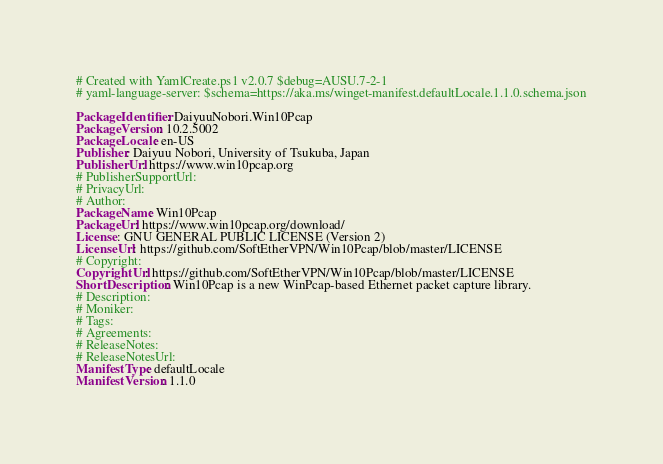Convert code to text. <code><loc_0><loc_0><loc_500><loc_500><_YAML_># Created with YamlCreate.ps1 v2.0.7 $debug=AUSU.7-2-1
# yaml-language-server: $schema=https://aka.ms/winget-manifest.defaultLocale.1.1.0.schema.json

PackageIdentifier: DaiyuuNobori.Win10Pcap
PackageVersion: 10.2.5002
PackageLocale: en-US
Publisher: Daiyuu Nobori, University of Tsukuba, Japan
PublisherUrl: https://www.win10pcap.org
# PublisherSupportUrl: 
# PrivacyUrl: 
# Author: 
PackageName: Win10Pcap
PackageUrl: https://www.win10pcap.org/download/
License: GNU GENERAL PUBLIC LICENSE (Version 2)
LicenseUrl: https://github.com/SoftEtherVPN/Win10Pcap/blob/master/LICENSE
# Copyright: 
CopyrightUrl: https://github.com/SoftEtherVPN/Win10Pcap/blob/master/LICENSE
ShortDescription: Win10Pcap is a new WinPcap-based Ethernet packet capture library.
# Description: 
# Moniker: 
# Tags: 
# Agreements: 
# ReleaseNotes: 
# ReleaseNotesUrl: 
ManifestType: defaultLocale
ManifestVersion: 1.1.0
</code> 